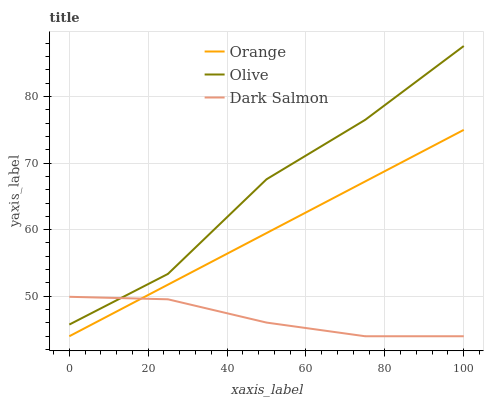Does Olive have the minimum area under the curve?
Answer yes or no. No. Does Dark Salmon have the maximum area under the curve?
Answer yes or no. No. Is Dark Salmon the smoothest?
Answer yes or no. No. Is Dark Salmon the roughest?
Answer yes or no. No. Does Olive have the lowest value?
Answer yes or no. No. Does Dark Salmon have the highest value?
Answer yes or no. No. Is Orange less than Olive?
Answer yes or no. Yes. Is Olive greater than Orange?
Answer yes or no. Yes. Does Orange intersect Olive?
Answer yes or no. No. 